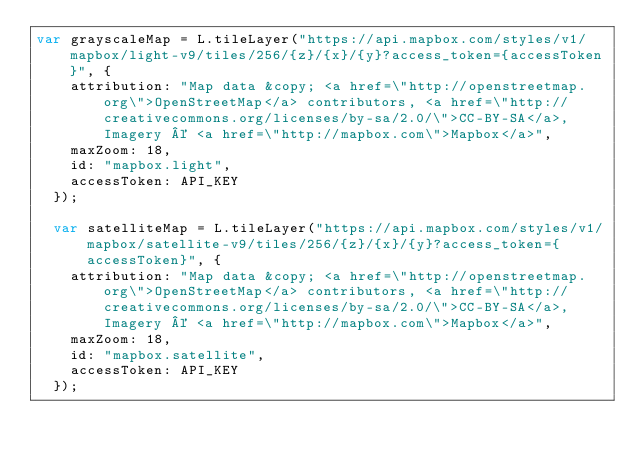Convert code to text. <code><loc_0><loc_0><loc_500><loc_500><_JavaScript_>var grayscaleMap = L.tileLayer("https://api.mapbox.com/styles/v1/mapbox/light-v9/tiles/256/{z}/{x}/{y}?access_token={accessToken}", {
    attribution: "Map data &copy; <a href=\"http://openstreetmap.org\">OpenStreetMap</a> contributors, <a href=\"http://creativecommons.org/licenses/by-sa/2.0/\">CC-BY-SA</a>, Imagery © <a href=\"http://mapbox.com\">Mapbox</a>",
    maxZoom: 18,
    id: "mapbox.light",
    accessToken: API_KEY
  });

  var satelliteMap = L.tileLayer("https://api.mapbox.com/styles/v1/mapbox/satellite-v9/tiles/256/{z}/{x}/{y}?access_token={accessToken}", {
    attribution: "Map data &copy; <a href=\"http://openstreetmap.org\">OpenStreetMap</a> contributors, <a href=\"http://creativecommons.org/licenses/by-sa/2.0/\">CC-BY-SA</a>, Imagery © <a href=\"http://mapbox.com\">Mapbox</a>",
    maxZoom: 18,
    id: "mapbox.satellite",
    accessToken: API_KEY
  });
  </code> 